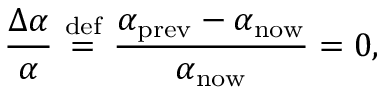Convert formula to latex. <formula><loc_0><loc_0><loc_500><loc_500>{ \frac { \Delta \alpha } { \alpha } } \ { \stackrel { d e f } { = } } \ { \frac { \alpha _ { p r e v } - \alpha _ { n o w } } { \alpha _ { n o w } } } = 0 ,</formula> 